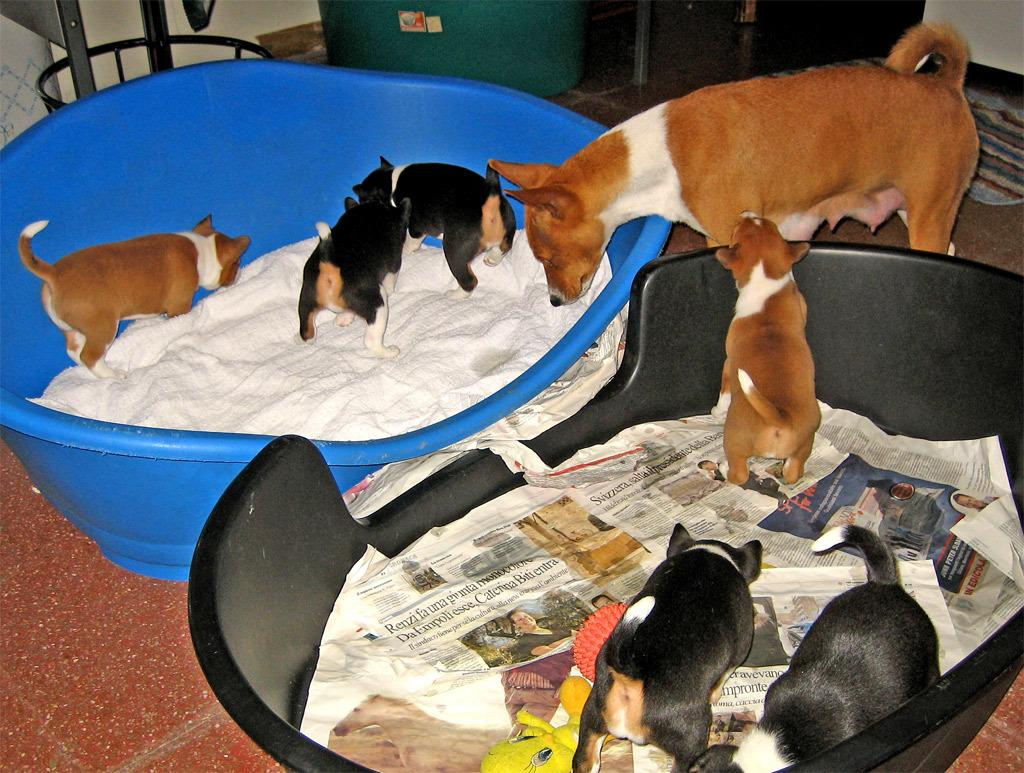What objects are on the floor in the image? There are tubs on the floor in the image. What animals can be seen in the image? There are dogs in the image. What can be used for reading in the image? Newspapers are present in the image. What items are related to clothing in the image? Clothes are visible in the image. What other objects are present in the image besides the ones mentioned? There are other objects in the image. What type of cat can be seen playing with a cherry in the image? There is no cat or cherry present in the image; it features tubs, dogs, newspapers, clothes, and other objects. 